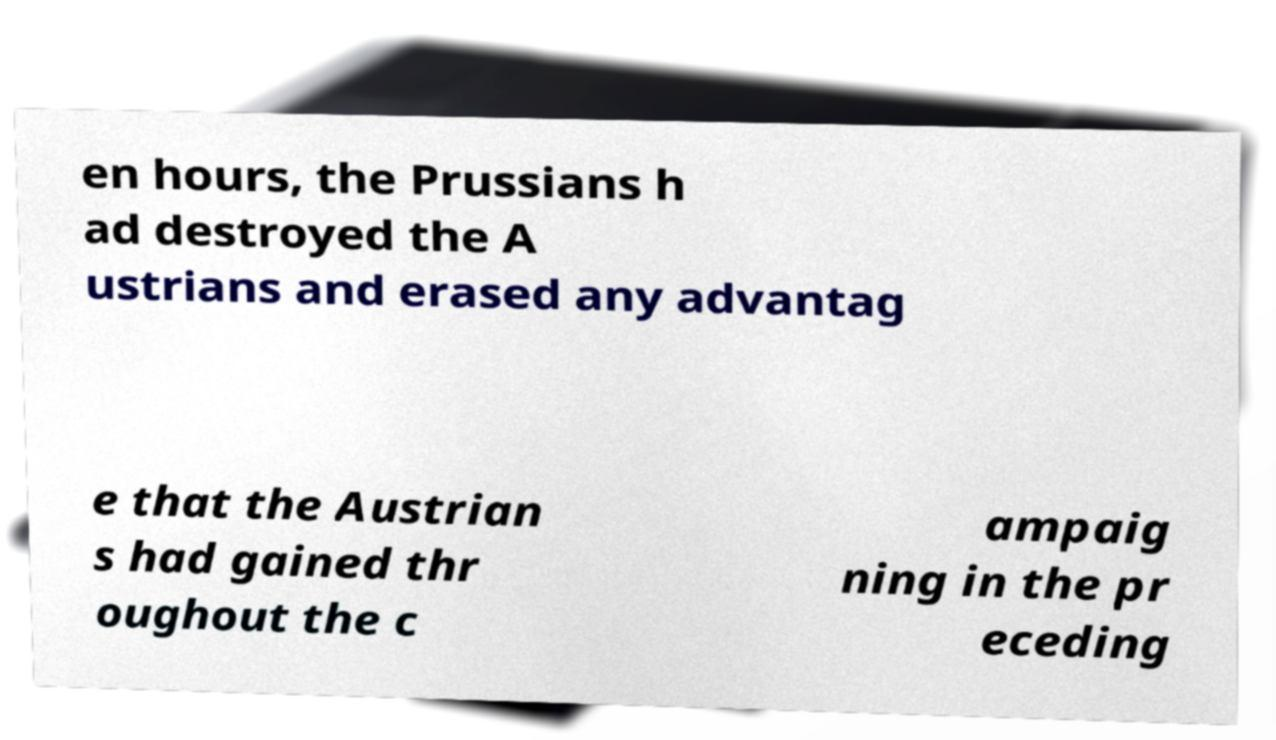There's text embedded in this image that I need extracted. Can you transcribe it verbatim? en hours, the Prussians h ad destroyed the A ustrians and erased any advantag e that the Austrian s had gained thr oughout the c ampaig ning in the pr eceding 